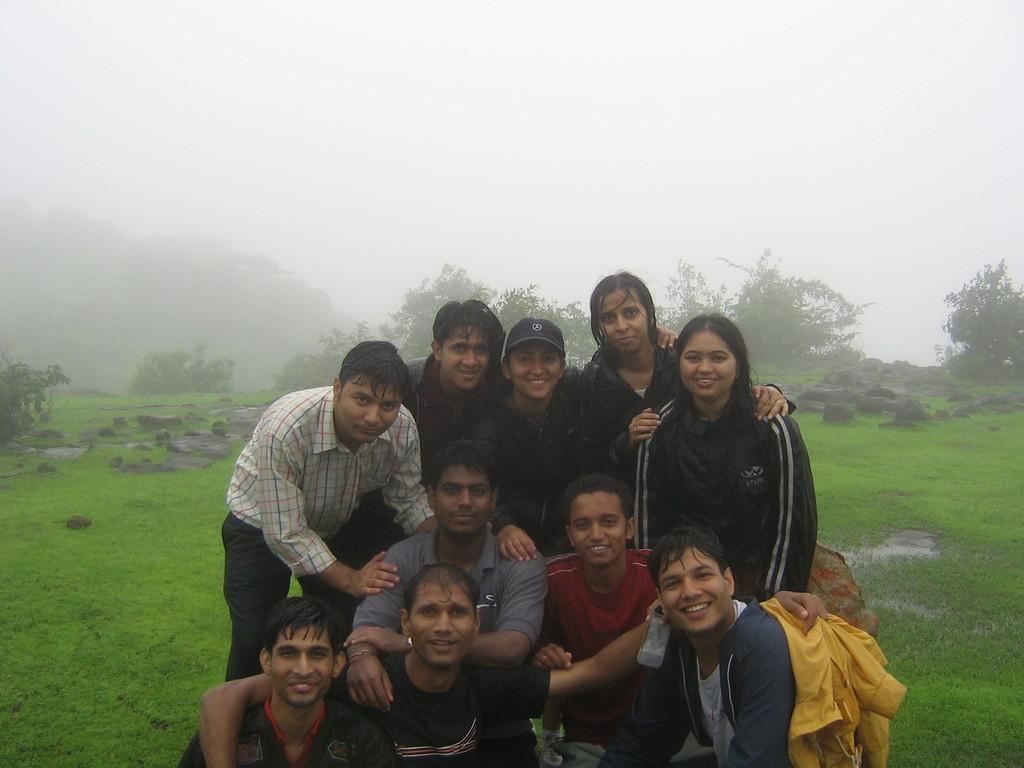In one or two sentences, can you explain what this image depicts? There are people in the foreground area of the image, there are trees, stones, grassland and the sky in the background. 